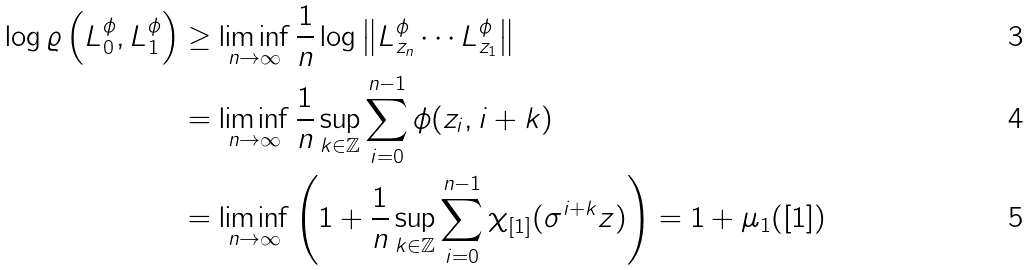Convert formula to latex. <formula><loc_0><loc_0><loc_500><loc_500>\log \varrho \left ( L _ { 0 } ^ { \phi } , L _ { 1 } ^ { \phi } \right ) & \geq \liminf _ { n \to \infty } \frac { 1 } { n } \log \left \| L ^ { \phi } _ { z _ { n } } \cdots L ^ { \phi } _ { z _ { 1 } } \right \| \\ & = \liminf _ { n \to \infty } \frac { 1 } { n } \sup _ { k \in \mathbb { Z } } \sum _ { i = 0 } ^ { n - 1 } \phi ( z _ { i } , i + k ) \\ & = \liminf _ { n \to \infty } \left ( 1 + \frac { 1 } { n } \sup _ { k \in \mathbb { Z } } \sum _ { i = 0 } ^ { n - 1 } \chi _ { [ 1 ] } ( \sigma ^ { i + k } z ) \right ) = 1 + \mu _ { 1 } ( [ 1 ] )</formula> 